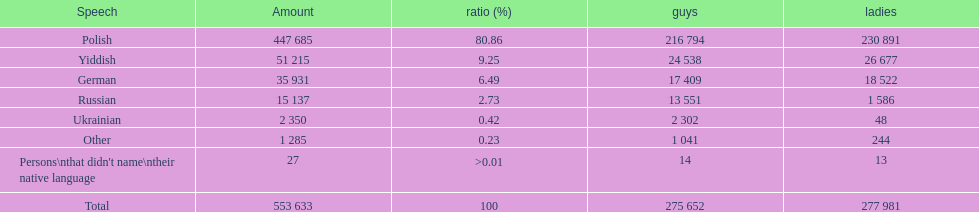Which language did only .42% of people in the imperial census of 1897 speak in the p&#322;ock governorate? Ukrainian. 